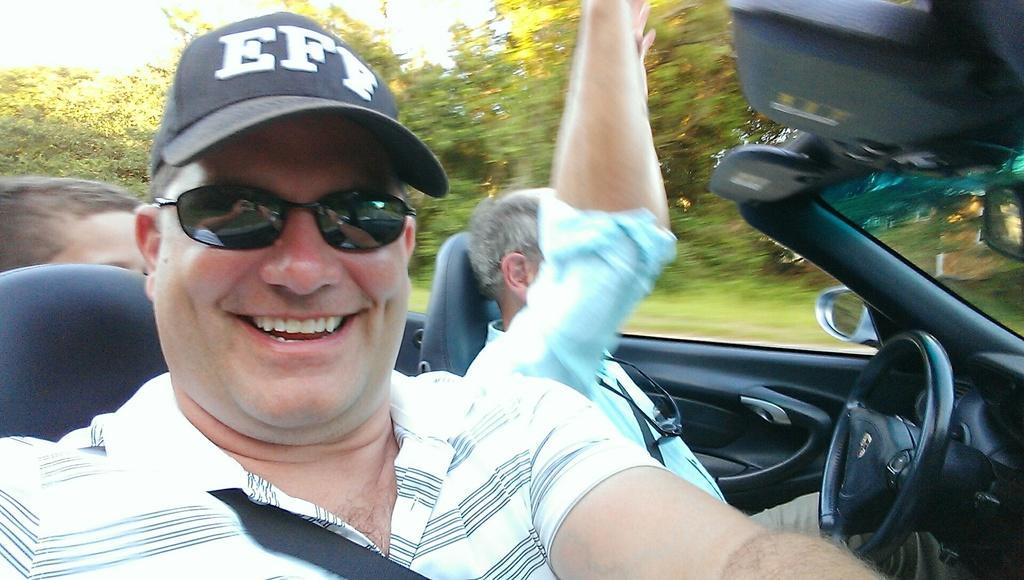Could you give a brief overview of what you see in this image? In this image I can see people are sitting in a car. This man is wearing a cap, black color shades and a t-shirt. In the background I can see trees. 